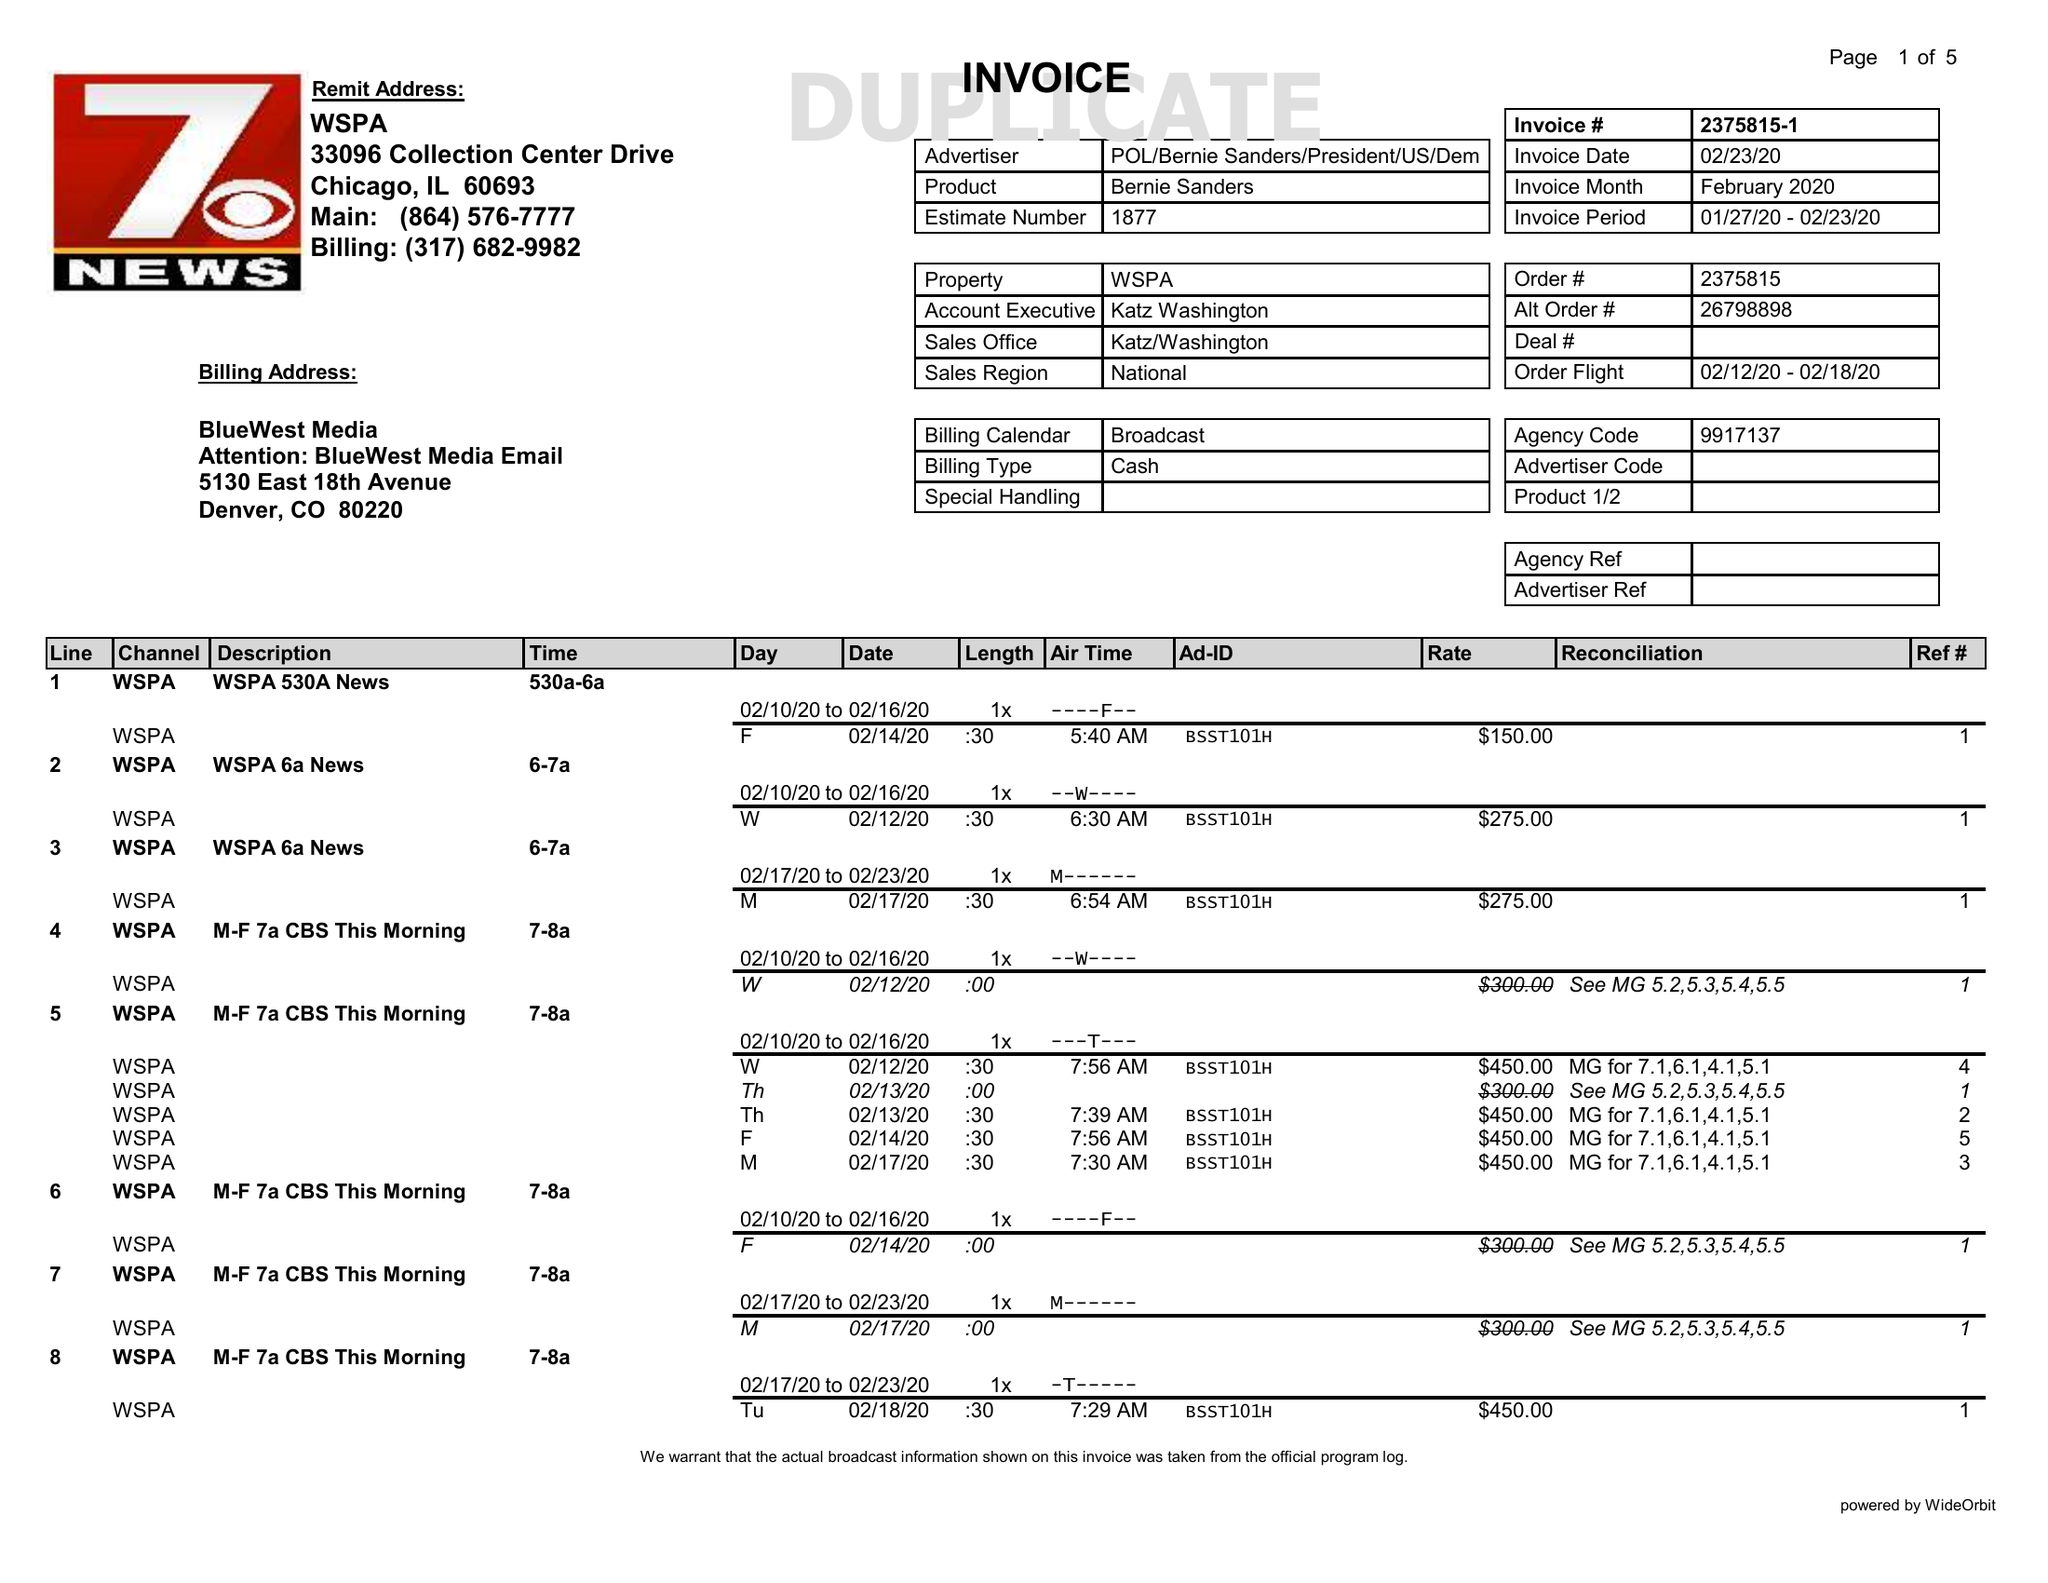What is the value for the flight_to?
Answer the question using a single word or phrase. 02/18/20 